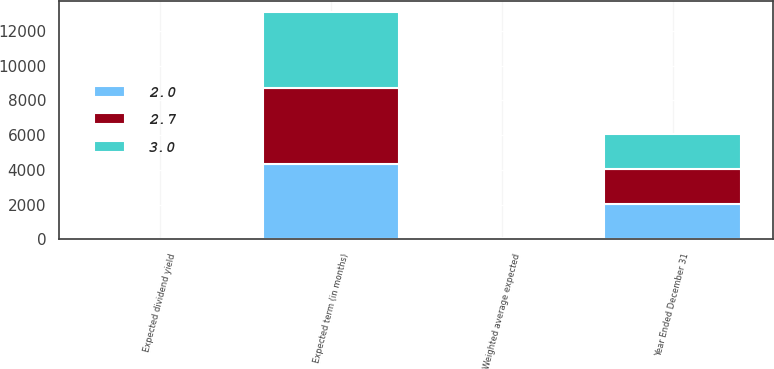Convert chart. <chart><loc_0><loc_0><loc_500><loc_500><stacked_bar_chart><ecel><fcel>Year Ended December 31<fcel>Weighted average expected<fcel>Expected term (in months)<fcel>Expected dividend yield<nl><fcel>2<fcel>2011<fcel>30.1<fcel>4353<fcel>2<nl><fcel>3<fcel>2012<fcel>30.7<fcel>4353<fcel>2.7<nl><fcel>2.7<fcel>2013<fcel>23.5<fcel>4353<fcel>3<nl></chart> 